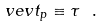Convert formula to latex. <formula><loc_0><loc_0><loc_500><loc_500>\ v e v { t _ { p } } \equiv \tau \ .</formula> 